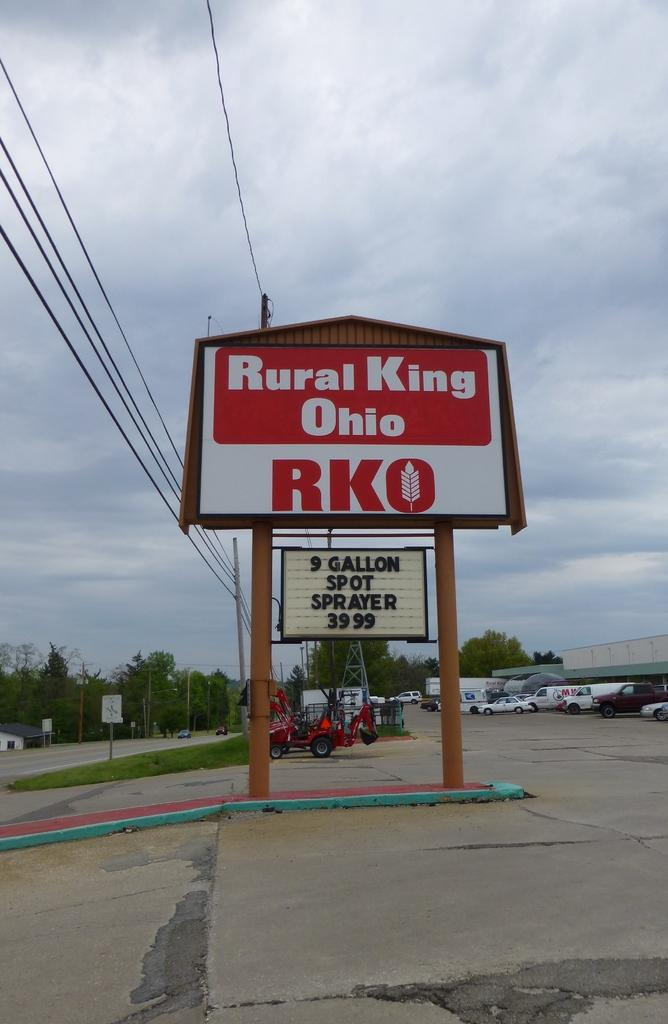<image>
Present a compact description of the photo's key features. Rural King Ohio is currently having a special on a 9 gallon spot sprayer 